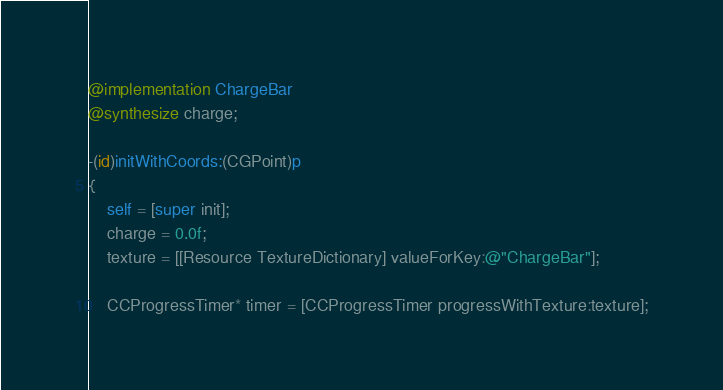<code> <loc_0><loc_0><loc_500><loc_500><_ObjectiveC_>

@implementation ChargeBar
@synthesize charge;

-(id)initWithCoords:(CGPoint)p
{
    self = [super init];
    charge = 0.0f;
	texture = [[Resource TextureDictionary] valueForKey:@"ChargeBar"];
    
    CCProgressTimer* timer = [CCProgressTimer progressWithTexture:texture];</code> 